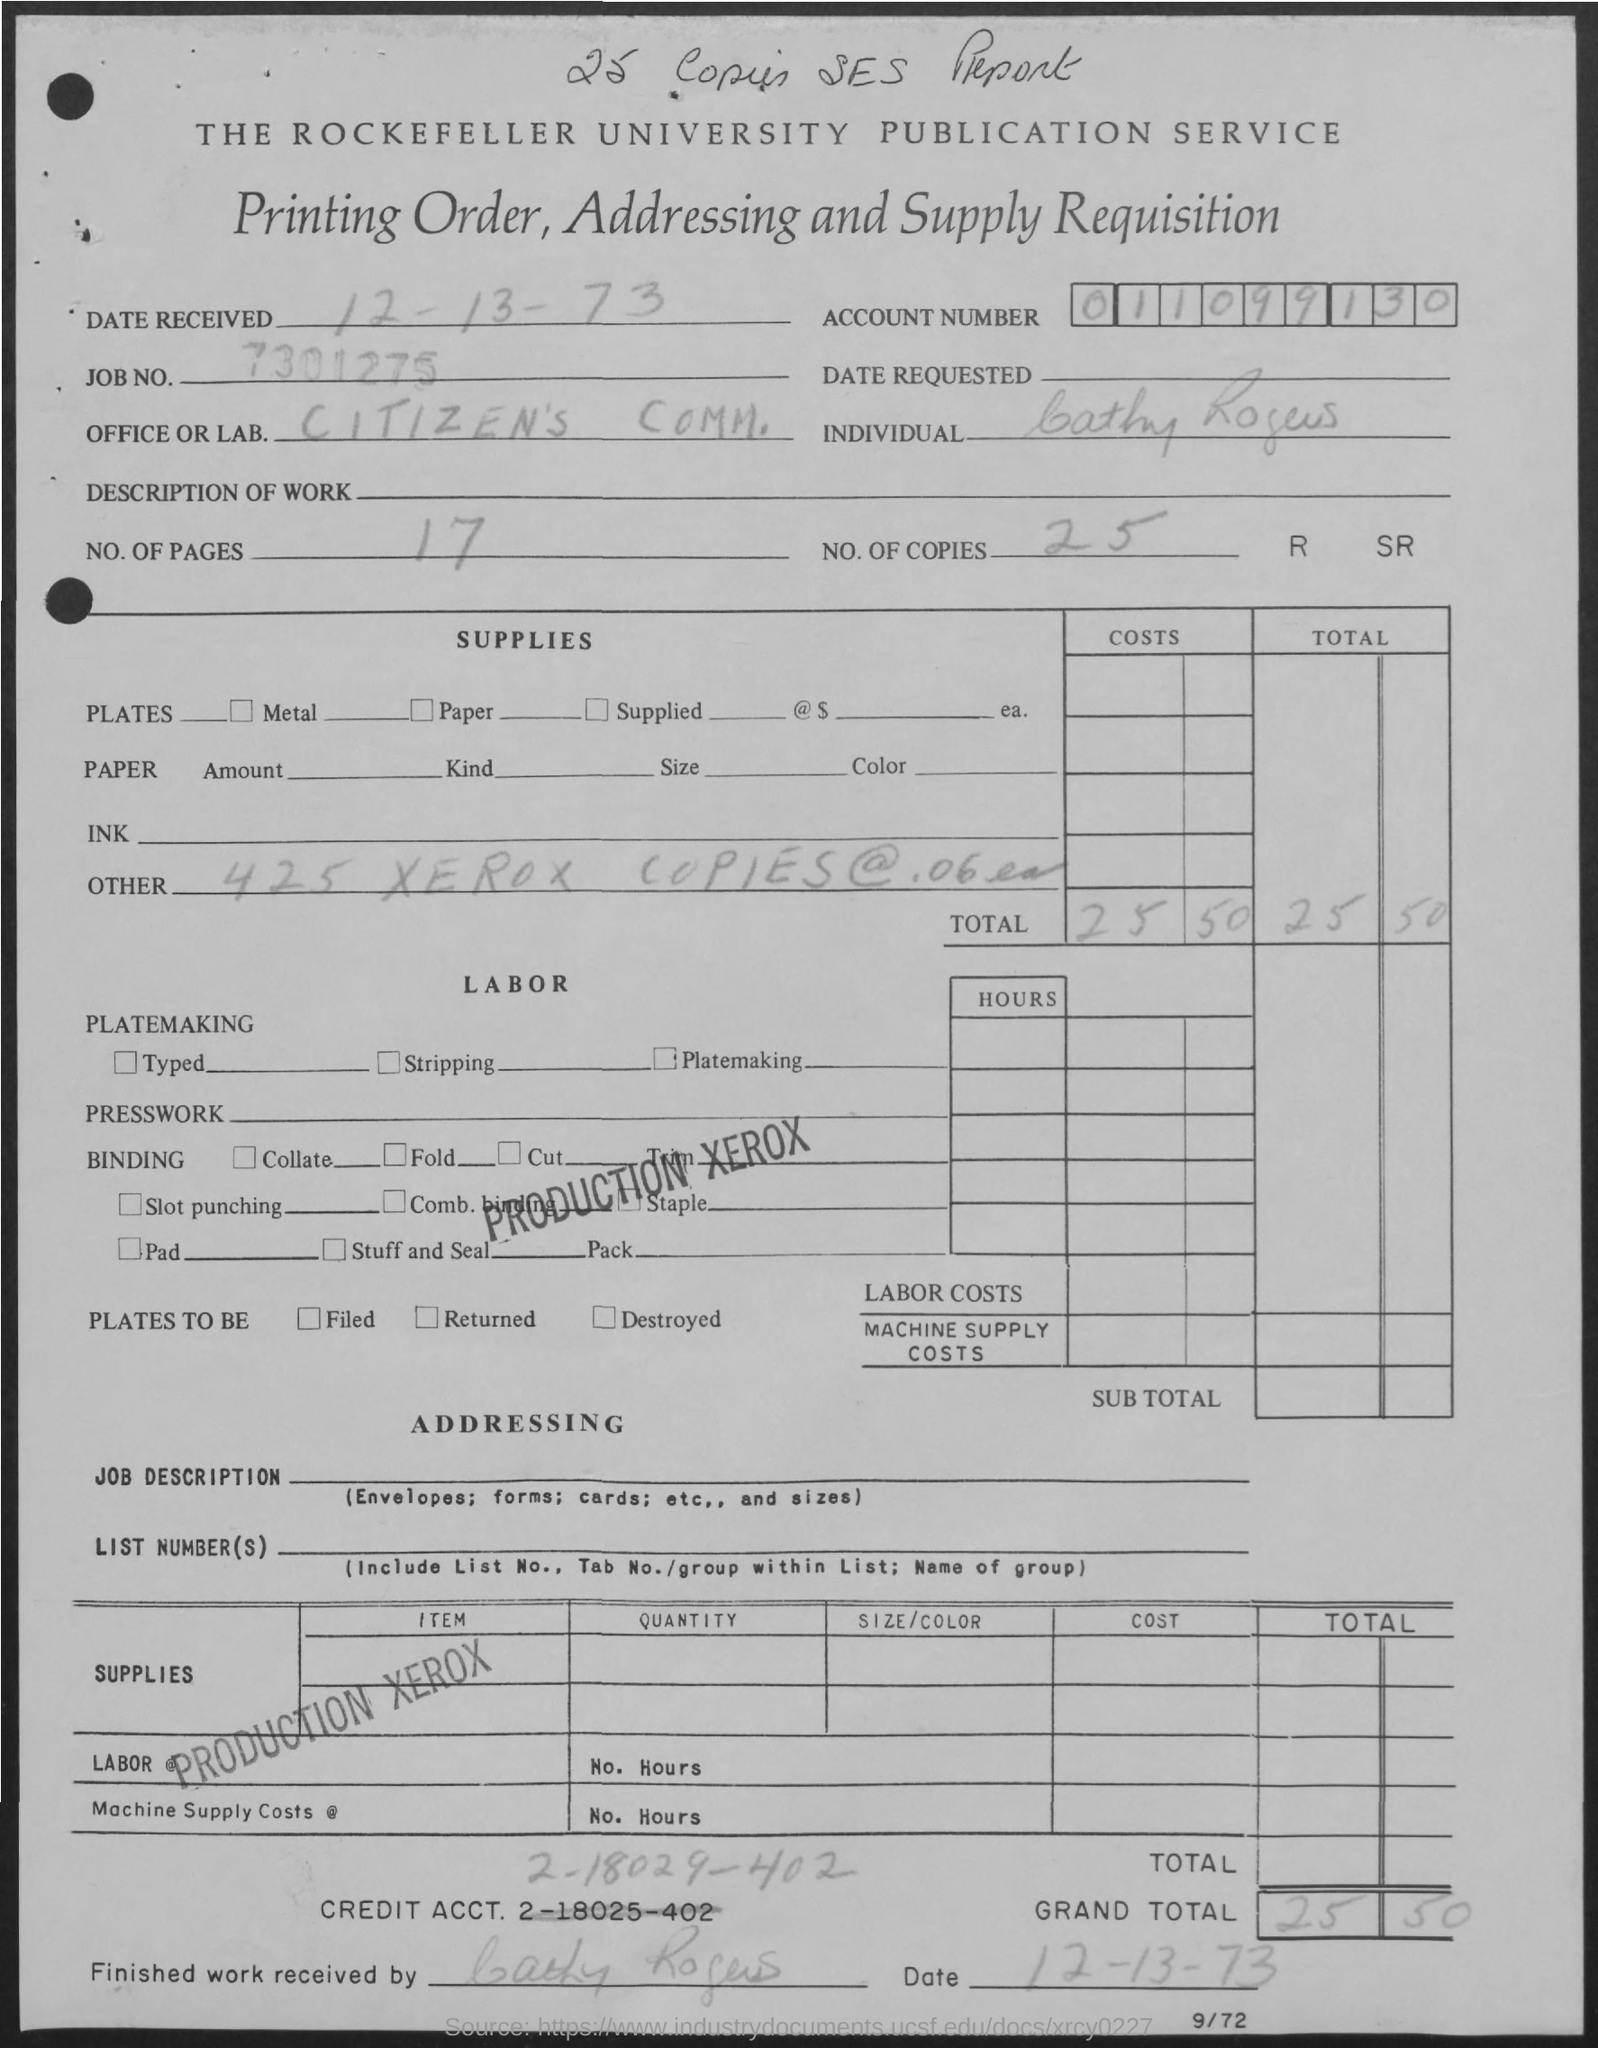What is the nature of the document displayed? This appears to be an archival form from The Rockefeller University Publication Service related to a printing order. It includes details about the number of pages, copies, and costs associated with printing, as well as the order and account number.  Can you tell me the date when the printing order was received? Yes, the printing order was received on December 13th, 1973, as indicated by the 'DATE RECEIVED' section at the top of the form. 